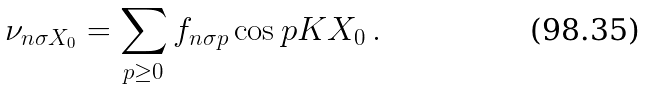<formula> <loc_0><loc_0><loc_500><loc_500>\nu _ { n \sigma X _ { 0 } } = \sum _ { p \geq 0 } f _ { n \sigma p } \cos p K X _ { 0 } \, .</formula> 